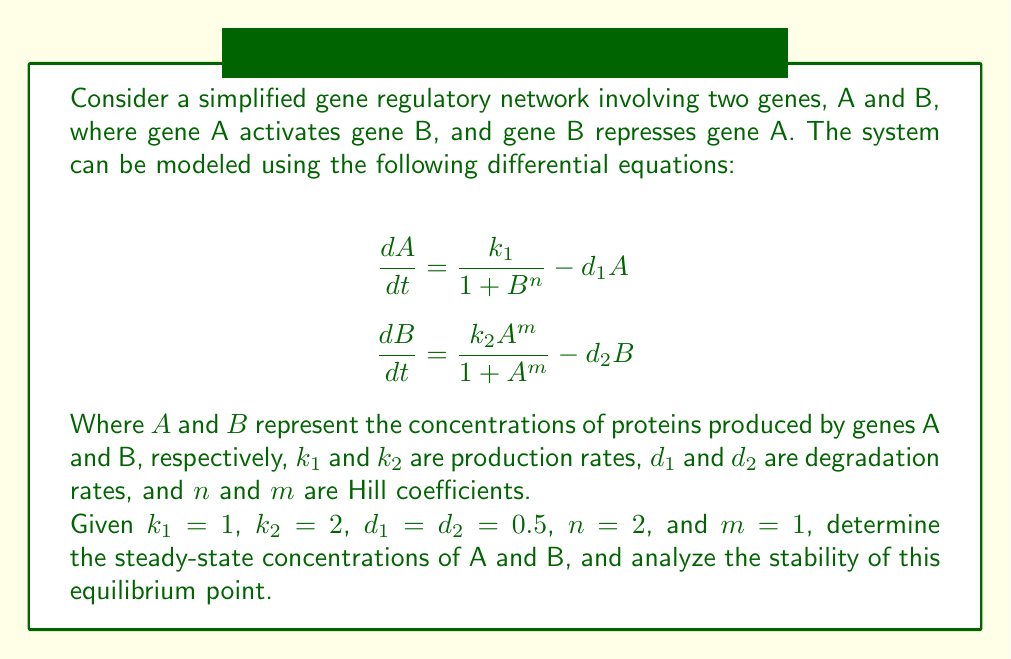Could you help me with this problem? To solve this problem, we'll follow these steps:

1. Find the steady-state concentrations by setting the differential equations to zero.
2. Solve the resulting system of algebraic equations.
3. Analyze the stability of the equilibrium point using linearization.

Step 1: Set the differential equations to zero:

$$0 = \frac{1}{1 + B^2} - 0.5A$$
$$0 = \frac{2A}{1 + A} - 0.5B$$

Step 2: Solve the system of equations:

From the first equation:
$$A = \frac{2}{1 + B^2}$$

Substituting this into the second equation:
$$0 = \frac{2(\frac{2}{1 + B^2})}{1 + \frac{2}{1 + B^2}} - 0.5B$$

Simplifying:
$$0 = \frac{4}{1 + B^2 + 2} - 0.5B$$
$$0 = \frac{4}{3 + B^2} - 0.5B$$

Multiplying both sides by $(3 + B^2)$:
$$0 = 4 - 0.5B(3 + B^2)$$
$$0 = 4 - 1.5B - 0.5B^3$$

This cubic equation can be solved numerically, yielding $B \approx 1.4142$.

Substituting this value back into the equation for $A$:
$$A = \frac{2}{1 + (1.4142)^2} \approx 0.5858$$

Step 3: Analyze stability using linearization:

Construct the Jacobian matrix:
$$J = \begin{bmatrix}
\frac{\partial}{\partial A}(\frac{1}{1 + B^2} - 0.5A) & \frac{\partial}{\partial B}(\frac{1}{1 + B^2} - 0.5A) \\
\frac{\partial}{\partial A}(\frac{2A}{1 + A} - 0.5B) & \frac{\partial}{\partial B}(\frac{2A}{1 + A} - 0.5B)
\end{bmatrix}$$

$$J = \begin{bmatrix}
-0.5 & \frac{-2B}{(1 + B^2)^2} \\
\frac{2}{(1 + A)^2} & -0.5
\end{bmatrix}$$

Evaluate the Jacobian at the equilibrium point $(A, B) \approx (0.5858, 1.4142)$:

$$J_{eq} \approx \begin{bmatrix}
-0.5 & -0.2929 \\
0.8284 & -0.5
\end{bmatrix}$$

The eigenvalues of this matrix are approximately $-0.5 \pm 0.4928i$. Since the real parts of both eigenvalues are negative, the equilibrium point is stable.
Answer: Steady-state: $A \approx 0.5858$, $B \approx 1.4142$. Stable equilibrium point. 